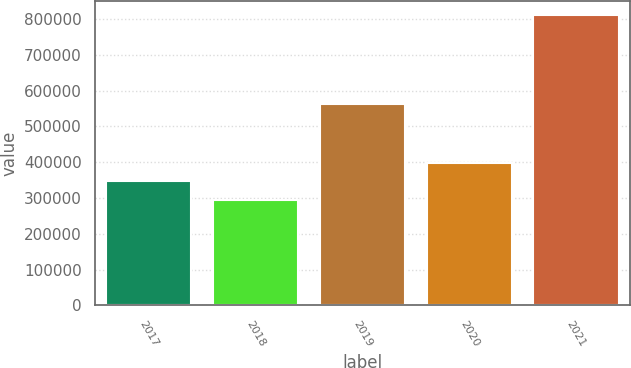Convert chart. <chart><loc_0><loc_0><loc_500><loc_500><bar_chart><fcel>2017<fcel>2018<fcel>2019<fcel>2020<fcel>2021<nl><fcel>346519<fcel>294260<fcel>562570<fcel>398218<fcel>811245<nl></chart> 